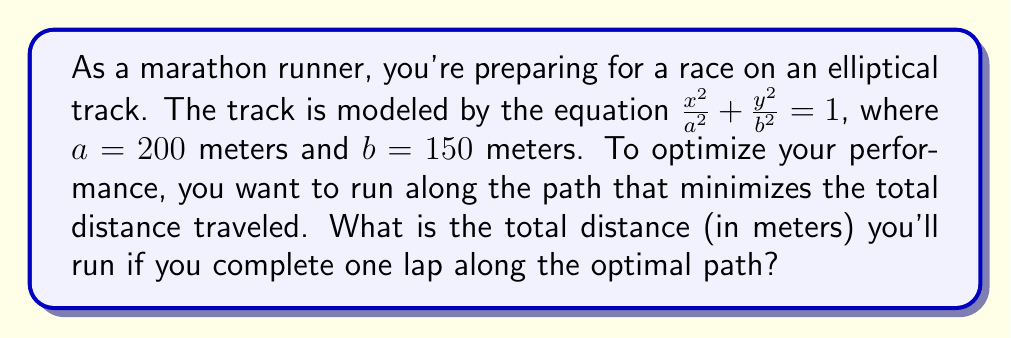Can you solve this math problem? To solve this problem, we'll follow these steps:

1) The optimal path on an elliptical track is along its circumference. We need to calculate the circumference of the ellipse.

2) The exact formula for the circumference of an ellipse is complex, involving elliptic integrals. However, we can use Ramanujan's approximation, which is very accurate:

   $$C \approx \pi(a+b)\left(1 + \frac{3h}{10 + \sqrt{4-3h}}\right)$$

   where $h = \frac{(a-b)^2}{(a+b)^2}$

3) Let's calculate $h$:
   $$h = \frac{(200-150)^2}{(200+150)^2} = \frac{2500}{122500} = \frac{1}{49}$$

4) Now, let's substitute this into Ramanujan's formula:

   $$C \approx \pi(200+150)\left(1 + \frac{3(\frac{1}{49})}{10 + \sqrt{4-3(\frac{1}{49})}}\right)$$

5) Simplify:
   $$C \approx 350\pi\left(1 + \frac{3/49}{10 + \sqrt{4-3/49}}\right)$$
   $$\approx 350\pi\left(1 + \frac{3/49}{10 + \sqrt{193/49}}\right)$$
   $$\approx 350\pi(1 + 0.0062)$$
   $$\approx 350\pi(1.0062)$$

6) Calculate the final result:
   $$C \approx 1100.6\pi \approx 3458.3 \text{ meters}$$

Therefore, the total distance you'll run in one lap along the optimal path is approximately 3458.3 meters.
Answer: $3458.3$ meters 